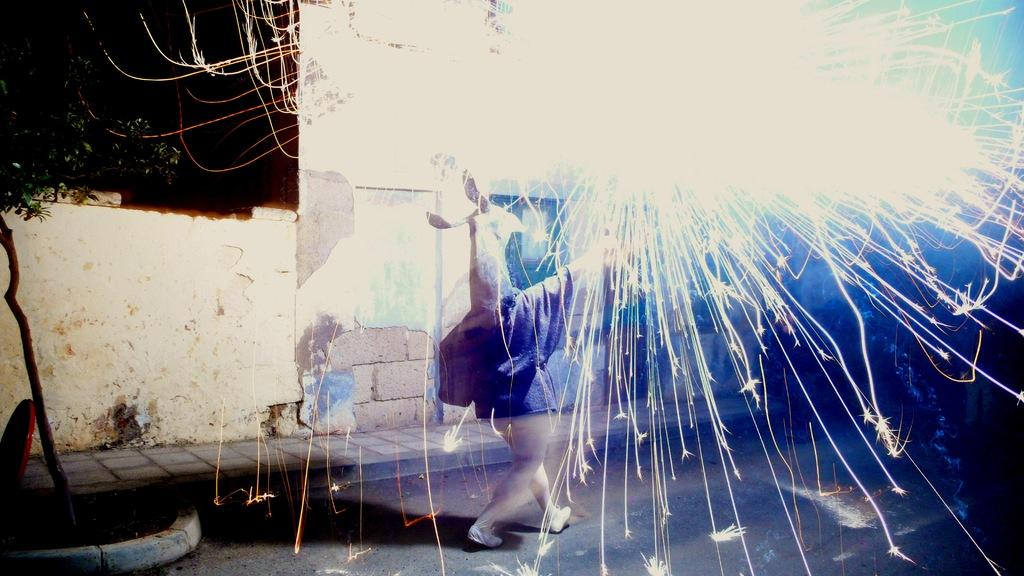What is the main subject of the image? There is a person in the image. Where is the person located? The person is on the road. What other elements can be seen in the image? There is a footpath, a tree, a wall, sparks, and some objects in the image. How would you describe the lighting in the image? The background of the image is dark. Can you see any ducks swimming in the harbor in the image? There is no harbor or ducks present in the image. 